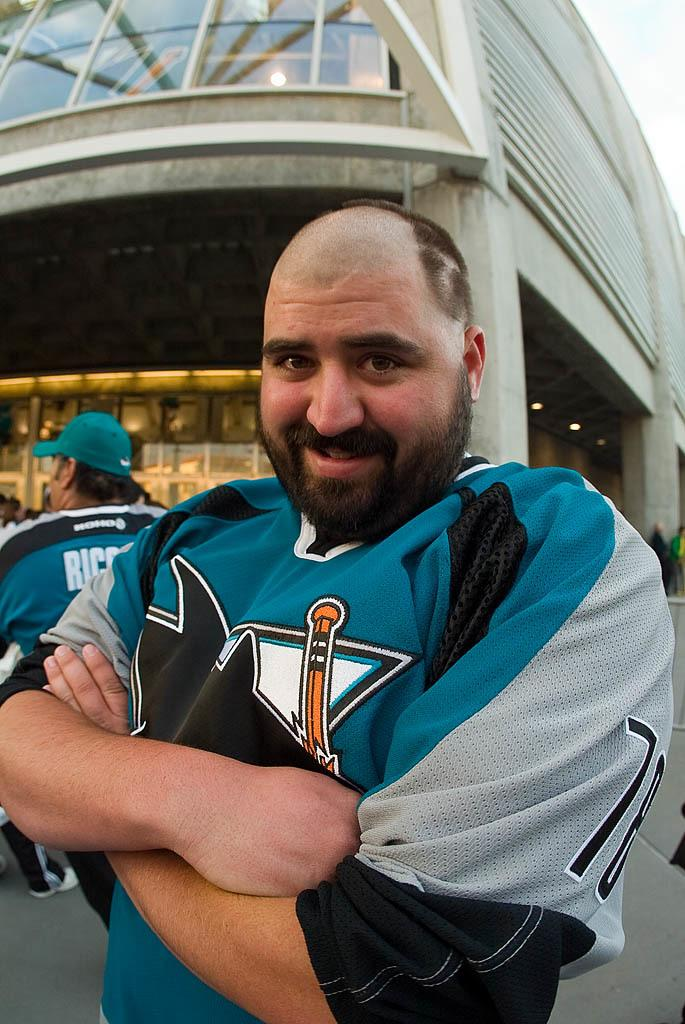<image>
Present a compact description of the photo's key features. A sports fan wearing a umber 78 jersey has shaved the front part of his hair to make it look like a receding hairline. 